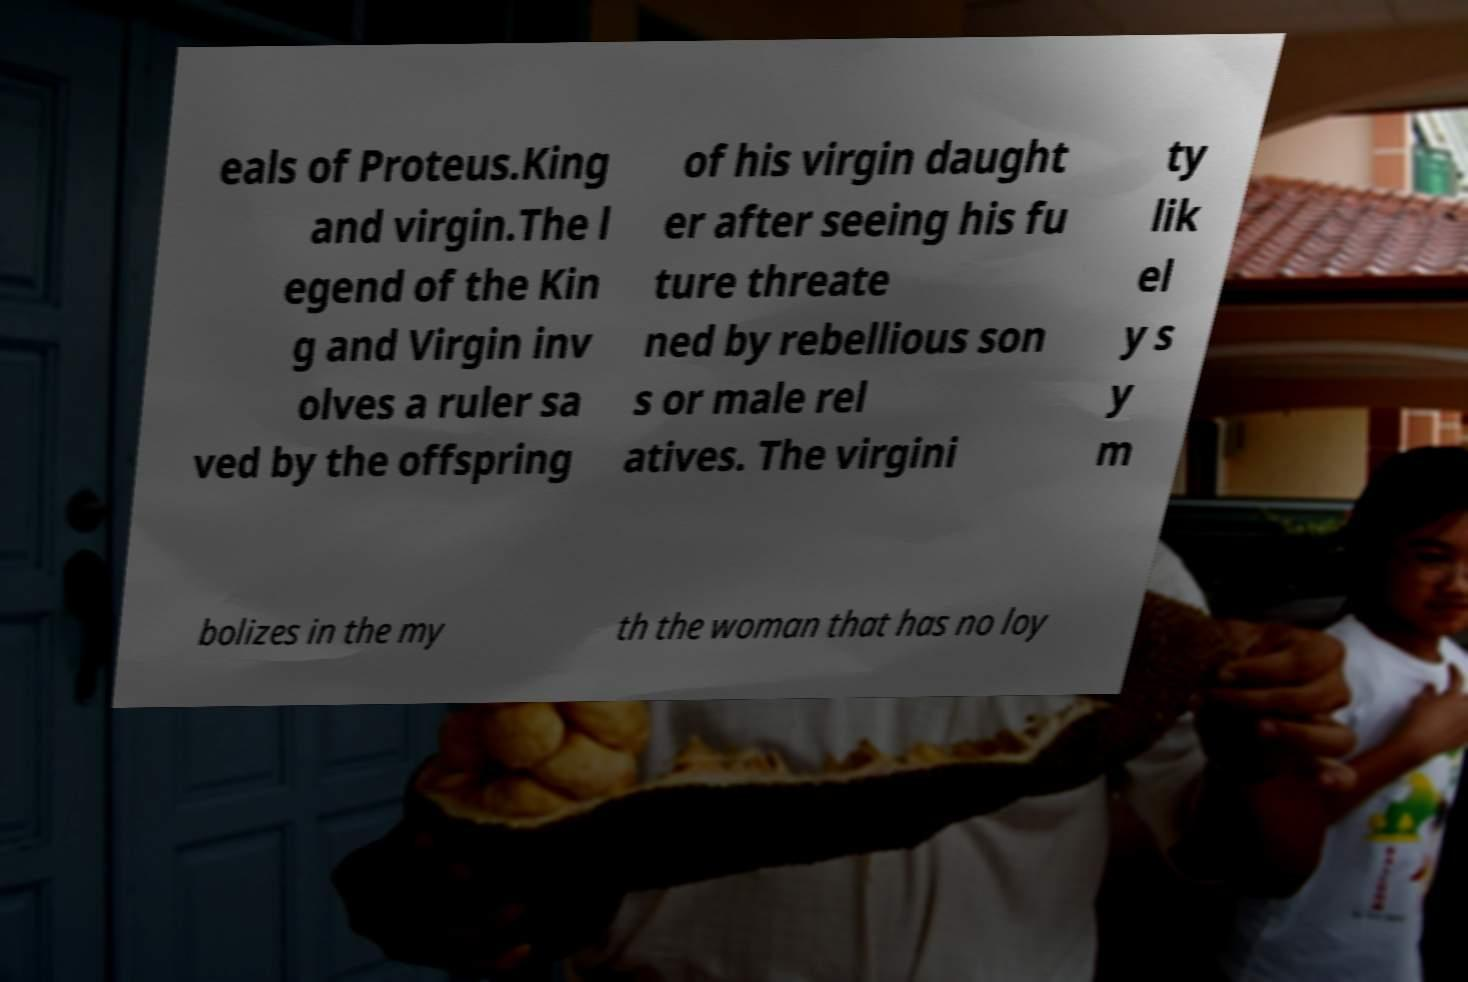Can you read and provide the text displayed in the image?This photo seems to have some interesting text. Can you extract and type it out for me? eals of Proteus.King and virgin.The l egend of the Kin g and Virgin inv olves a ruler sa ved by the offspring of his virgin daught er after seeing his fu ture threate ned by rebellious son s or male rel atives. The virgini ty lik el y s y m bolizes in the my th the woman that has no loy 